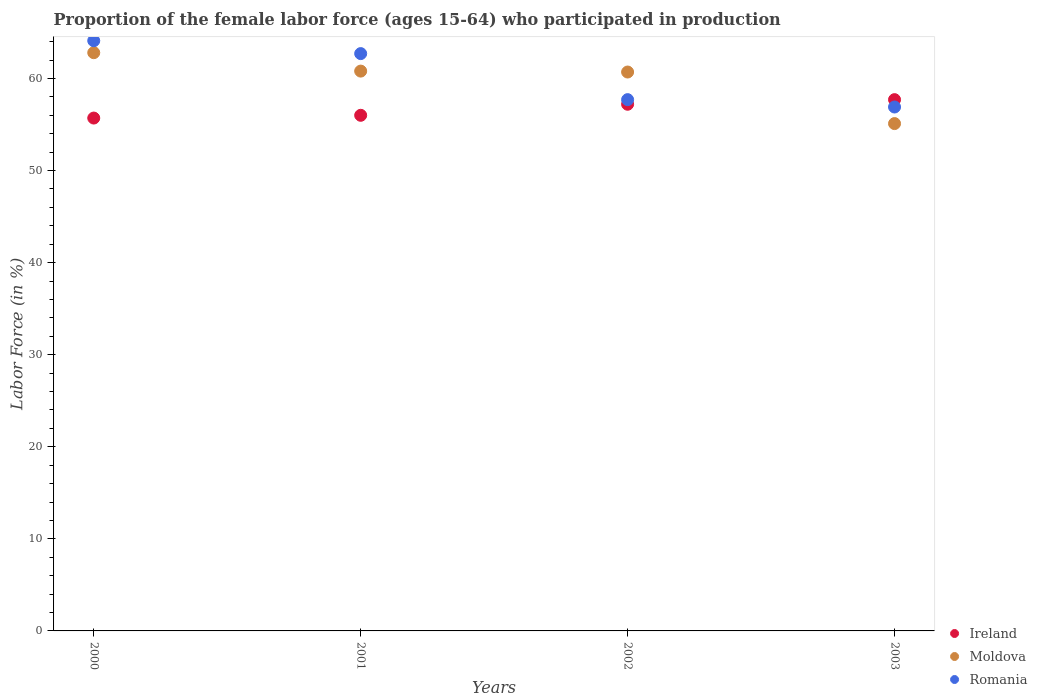How many different coloured dotlines are there?
Your response must be concise. 3. Is the number of dotlines equal to the number of legend labels?
Your answer should be compact. Yes. What is the proportion of the female labor force who participated in production in Romania in 2001?
Make the answer very short. 62.7. Across all years, what is the maximum proportion of the female labor force who participated in production in Romania?
Offer a terse response. 64.1. Across all years, what is the minimum proportion of the female labor force who participated in production in Romania?
Offer a terse response. 56.9. What is the total proportion of the female labor force who participated in production in Romania in the graph?
Your response must be concise. 241.4. What is the difference between the proportion of the female labor force who participated in production in Moldova in 2001 and that in 2003?
Offer a terse response. 5.7. What is the difference between the proportion of the female labor force who participated in production in Moldova in 2003 and the proportion of the female labor force who participated in production in Ireland in 2000?
Your response must be concise. -0.6. What is the average proportion of the female labor force who participated in production in Ireland per year?
Offer a terse response. 56.65. In the year 2000, what is the difference between the proportion of the female labor force who participated in production in Moldova and proportion of the female labor force who participated in production in Romania?
Offer a terse response. -1.3. What is the ratio of the proportion of the female labor force who participated in production in Romania in 2000 to that in 2003?
Keep it short and to the point. 1.13. Is the proportion of the female labor force who participated in production in Romania in 2000 less than that in 2003?
Keep it short and to the point. No. What is the difference between the highest and the second highest proportion of the female labor force who participated in production in Ireland?
Make the answer very short. 0.5. What is the difference between the highest and the lowest proportion of the female labor force who participated in production in Romania?
Provide a short and direct response. 7.2. Is it the case that in every year, the sum of the proportion of the female labor force who participated in production in Ireland and proportion of the female labor force who participated in production in Moldova  is greater than the proportion of the female labor force who participated in production in Romania?
Offer a terse response. Yes. Does the proportion of the female labor force who participated in production in Romania monotonically increase over the years?
Your answer should be very brief. No. Is the proportion of the female labor force who participated in production in Romania strictly less than the proportion of the female labor force who participated in production in Ireland over the years?
Offer a very short reply. No. What is the difference between two consecutive major ticks on the Y-axis?
Offer a terse response. 10. Are the values on the major ticks of Y-axis written in scientific E-notation?
Keep it short and to the point. No. Does the graph contain any zero values?
Give a very brief answer. No. Where does the legend appear in the graph?
Your answer should be very brief. Bottom right. How many legend labels are there?
Provide a short and direct response. 3. What is the title of the graph?
Ensure brevity in your answer.  Proportion of the female labor force (ages 15-64) who participated in production. Does "Swaziland" appear as one of the legend labels in the graph?
Provide a succinct answer. No. What is the label or title of the Y-axis?
Your answer should be very brief. Labor Force (in %). What is the Labor Force (in %) of Ireland in 2000?
Make the answer very short. 55.7. What is the Labor Force (in %) in Moldova in 2000?
Offer a very short reply. 62.8. What is the Labor Force (in %) of Romania in 2000?
Make the answer very short. 64.1. What is the Labor Force (in %) in Ireland in 2001?
Provide a succinct answer. 56. What is the Labor Force (in %) of Moldova in 2001?
Give a very brief answer. 60.8. What is the Labor Force (in %) in Romania in 2001?
Offer a terse response. 62.7. What is the Labor Force (in %) of Ireland in 2002?
Your response must be concise. 57.2. What is the Labor Force (in %) of Moldova in 2002?
Offer a terse response. 60.7. What is the Labor Force (in %) of Romania in 2002?
Your answer should be very brief. 57.7. What is the Labor Force (in %) in Ireland in 2003?
Keep it short and to the point. 57.7. What is the Labor Force (in %) of Moldova in 2003?
Your answer should be very brief. 55.1. What is the Labor Force (in %) of Romania in 2003?
Your answer should be compact. 56.9. Across all years, what is the maximum Labor Force (in %) in Ireland?
Give a very brief answer. 57.7. Across all years, what is the maximum Labor Force (in %) of Moldova?
Offer a terse response. 62.8. Across all years, what is the maximum Labor Force (in %) in Romania?
Your answer should be compact. 64.1. Across all years, what is the minimum Labor Force (in %) in Ireland?
Keep it short and to the point. 55.7. Across all years, what is the minimum Labor Force (in %) in Moldova?
Offer a terse response. 55.1. Across all years, what is the minimum Labor Force (in %) in Romania?
Your answer should be compact. 56.9. What is the total Labor Force (in %) in Ireland in the graph?
Offer a very short reply. 226.6. What is the total Labor Force (in %) in Moldova in the graph?
Offer a very short reply. 239.4. What is the total Labor Force (in %) of Romania in the graph?
Provide a short and direct response. 241.4. What is the difference between the Labor Force (in %) in Ireland in 2000 and that in 2001?
Make the answer very short. -0.3. What is the difference between the Labor Force (in %) of Romania in 2000 and that in 2001?
Offer a very short reply. 1.4. What is the difference between the Labor Force (in %) of Ireland in 2000 and that in 2002?
Provide a succinct answer. -1.5. What is the difference between the Labor Force (in %) of Romania in 2000 and that in 2002?
Make the answer very short. 6.4. What is the difference between the Labor Force (in %) of Ireland in 2000 and that in 2003?
Provide a short and direct response. -2. What is the difference between the Labor Force (in %) of Romania in 2000 and that in 2003?
Give a very brief answer. 7.2. What is the difference between the Labor Force (in %) in Ireland in 2001 and that in 2002?
Your response must be concise. -1.2. What is the difference between the Labor Force (in %) in Moldova in 2001 and that in 2002?
Make the answer very short. 0.1. What is the difference between the Labor Force (in %) of Moldova in 2001 and that in 2003?
Provide a short and direct response. 5.7. What is the difference between the Labor Force (in %) of Romania in 2001 and that in 2003?
Give a very brief answer. 5.8. What is the difference between the Labor Force (in %) in Ireland in 2000 and the Labor Force (in %) in Romania in 2001?
Your answer should be compact. -7. What is the difference between the Labor Force (in %) in Ireland in 2000 and the Labor Force (in %) in Romania in 2002?
Make the answer very short. -2. What is the difference between the Labor Force (in %) of Moldova in 2000 and the Labor Force (in %) of Romania in 2002?
Give a very brief answer. 5.1. What is the difference between the Labor Force (in %) in Ireland in 2000 and the Labor Force (in %) in Romania in 2003?
Provide a short and direct response. -1.2. What is the difference between the Labor Force (in %) of Moldova in 2000 and the Labor Force (in %) of Romania in 2003?
Give a very brief answer. 5.9. What is the difference between the Labor Force (in %) of Ireland in 2001 and the Labor Force (in %) of Romania in 2002?
Provide a succinct answer. -1.7. What is the difference between the Labor Force (in %) in Moldova in 2001 and the Labor Force (in %) in Romania in 2002?
Your response must be concise. 3.1. What is the difference between the Labor Force (in %) of Ireland in 2001 and the Labor Force (in %) of Romania in 2003?
Make the answer very short. -0.9. What is the difference between the Labor Force (in %) in Ireland in 2002 and the Labor Force (in %) in Romania in 2003?
Provide a succinct answer. 0.3. What is the average Labor Force (in %) of Ireland per year?
Your response must be concise. 56.65. What is the average Labor Force (in %) of Moldova per year?
Keep it short and to the point. 59.85. What is the average Labor Force (in %) in Romania per year?
Your response must be concise. 60.35. In the year 2000, what is the difference between the Labor Force (in %) of Ireland and Labor Force (in %) of Moldova?
Provide a short and direct response. -7.1. In the year 2000, what is the difference between the Labor Force (in %) in Moldova and Labor Force (in %) in Romania?
Ensure brevity in your answer.  -1.3. In the year 2002, what is the difference between the Labor Force (in %) in Moldova and Labor Force (in %) in Romania?
Make the answer very short. 3. In the year 2003, what is the difference between the Labor Force (in %) in Ireland and Labor Force (in %) in Moldova?
Provide a succinct answer. 2.6. In the year 2003, what is the difference between the Labor Force (in %) of Ireland and Labor Force (in %) of Romania?
Offer a terse response. 0.8. In the year 2003, what is the difference between the Labor Force (in %) of Moldova and Labor Force (in %) of Romania?
Your response must be concise. -1.8. What is the ratio of the Labor Force (in %) in Ireland in 2000 to that in 2001?
Give a very brief answer. 0.99. What is the ratio of the Labor Force (in %) of Moldova in 2000 to that in 2001?
Your response must be concise. 1.03. What is the ratio of the Labor Force (in %) in Romania in 2000 to that in 2001?
Give a very brief answer. 1.02. What is the ratio of the Labor Force (in %) of Ireland in 2000 to that in 2002?
Your answer should be very brief. 0.97. What is the ratio of the Labor Force (in %) in Moldova in 2000 to that in 2002?
Your answer should be compact. 1.03. What is the ratio of the Labor Force (in %) of Romania in 2000 to that in 2002?
Offer a very short reply. 1.11. What is the ratio of the Labor Force (in %) of Ireland in 2000 to that in 2003?
Ensure brevity in your answer.  0.97. What is the ratio of the Labor Force (in %) in Moldova in 2000 to that in 2003?
Offer a very short reply. 1.14. What is the ratio of the Labor Force (in %) of Romania in 2000 to that in 2003?
Provide a short and direct response. 1.13. What is the ratio of the Labor Force (in %) in Romania in 2001 to that in 2002?
Offer a very short reply. 1.09. What is the ratio of the Labor Force (in %) in Ireland in 2001 to that in 2003?
Provide a short and direct response. 0.97. What is the ratio of the Labor Force (in %) in Moldova in 2001 to that in 2003?
Provide a short and direct response. 1.1. What is the ratio of the Labor Force (in %) of Romania in 2001 to that in 2003?
Offer a terse response. 1.1. What is the ratio of the Labor Force (in %) of Moldova in 2002 to that in 2003?
Ensure brevity in your answer.  1.1. What is the ratio of the Labor Force (in %) of Romania in 2002 to that in 2003?
Offer a terse response. 1.01. What is the difference between the highest and the second highest Labor Force (in %) of Ireland?
Make the answer very short. 0.5. What is the difference between the highest and the second highest Labor Force (in %) in Romania?
Make the answer very short. 1.4. 